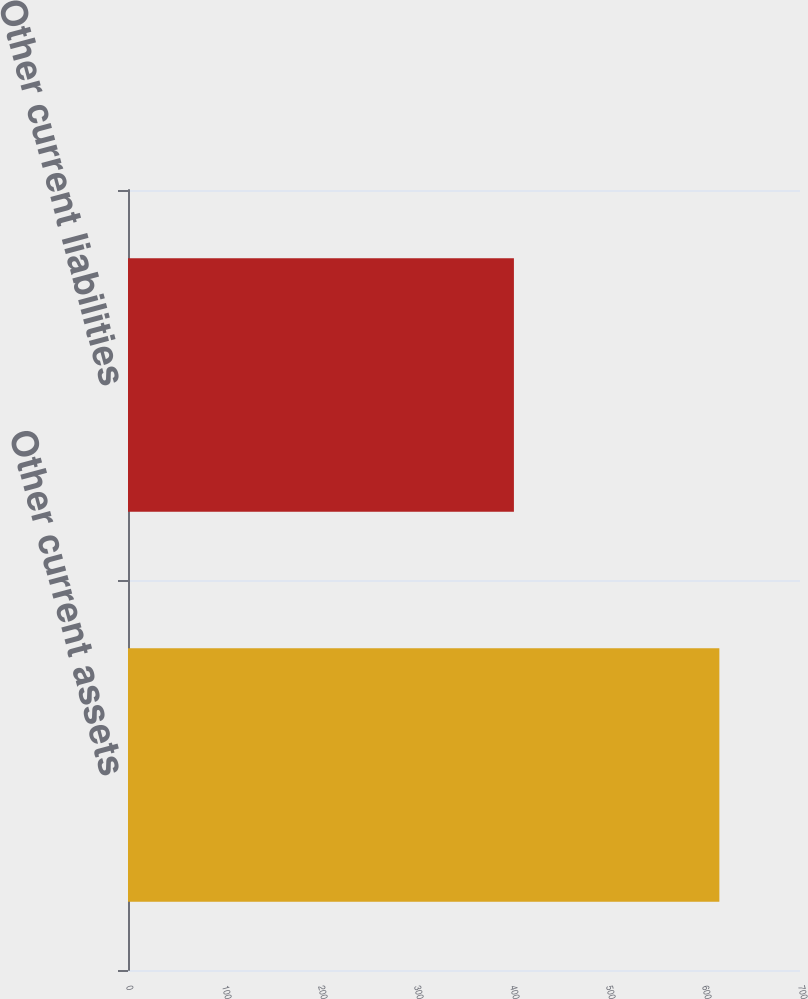<chart> <loc_0><loc_0><loc_500><loc_500><bar_chart><fcel>Other current assets<fcel>Other current liabilities<nl><fcel>616<fcel>402<nl></chart> 